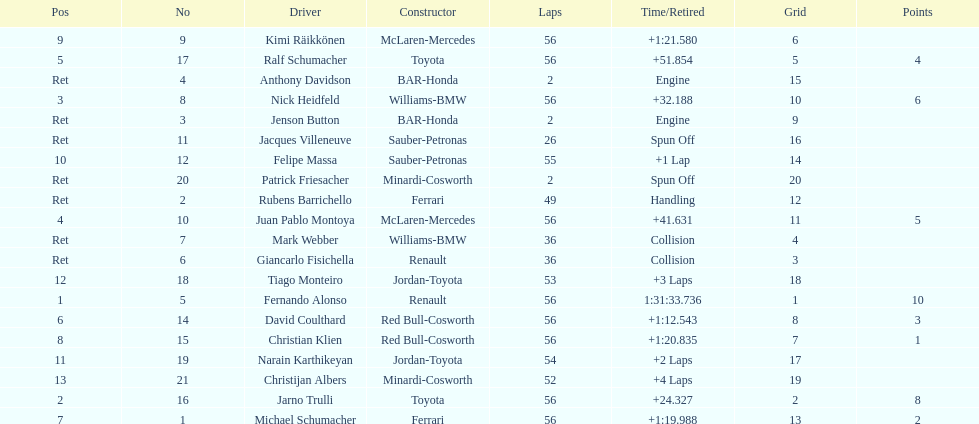How many drivers were retired before the race could end? 7. 